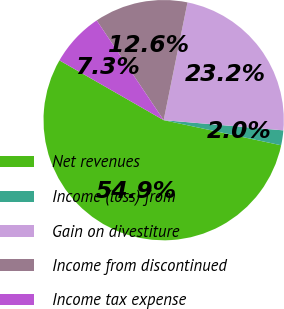Convert chart to OTSL. <chart><loc_0><loc_0><loc_500><loc_500><pie_chart><fcel>Net revenues<fcel>Income (loss) from<fcel>Gain on divestiture<fcel>Income from discontinued<fcel>Income tax expense<nl><fcel>54.94%<fcel>2.0%<fcel>23.18%<fcel>12.59%<fcel>7.3%<nl></chart> 